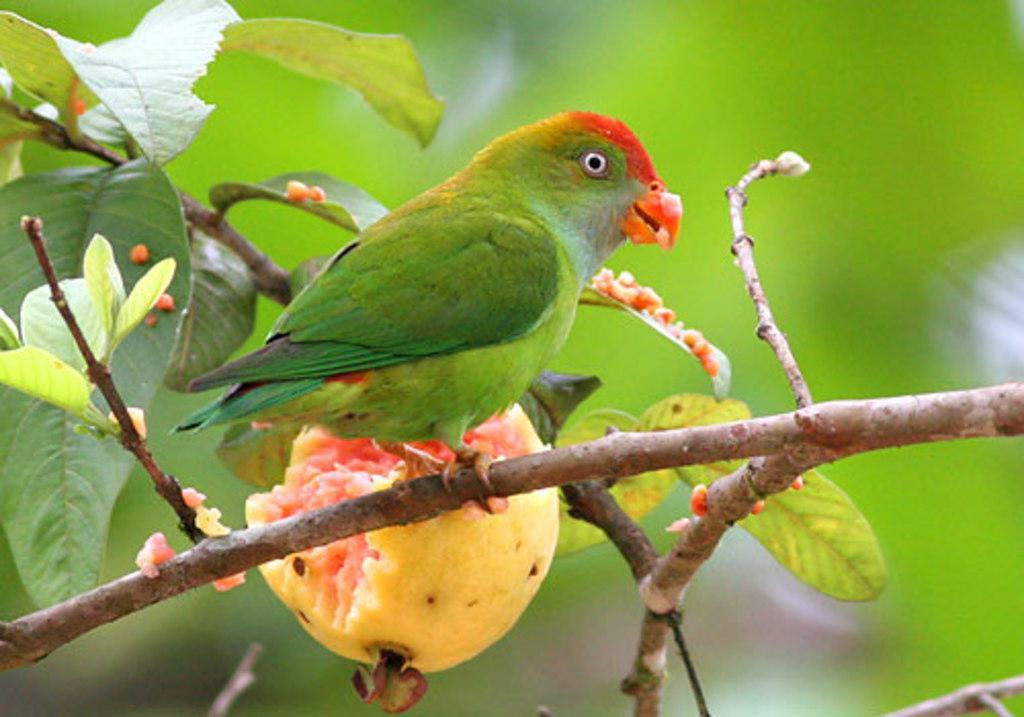How would you summarize this image in a sentence or two? In the center of the image we can see a parrot on the tree and there is a guava to the plant. We can see leaves. 